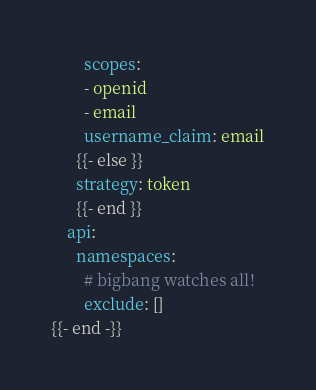Convert code to text. <code><loc_0><loc_0><loc_500><loc_500><_YAML_>        scopes:
        - openid
        - email
        username_claim: email
      {{- else }}
      strategy: token
      {{- end }}
    api:
      namespaces:
        # bigbang watches all!
        exclude: []
{{- end -}}
</code> 